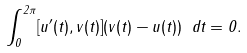<formula> <loc_0><loc_0><loc_500><loc_500>\int _ { 0 } ^ { 2 \pi } [ u ^ { \prime } ( t ) , v ( t ) ] ( v ( t ) - u ( t ) ) \ d t = 0 .</formula> 